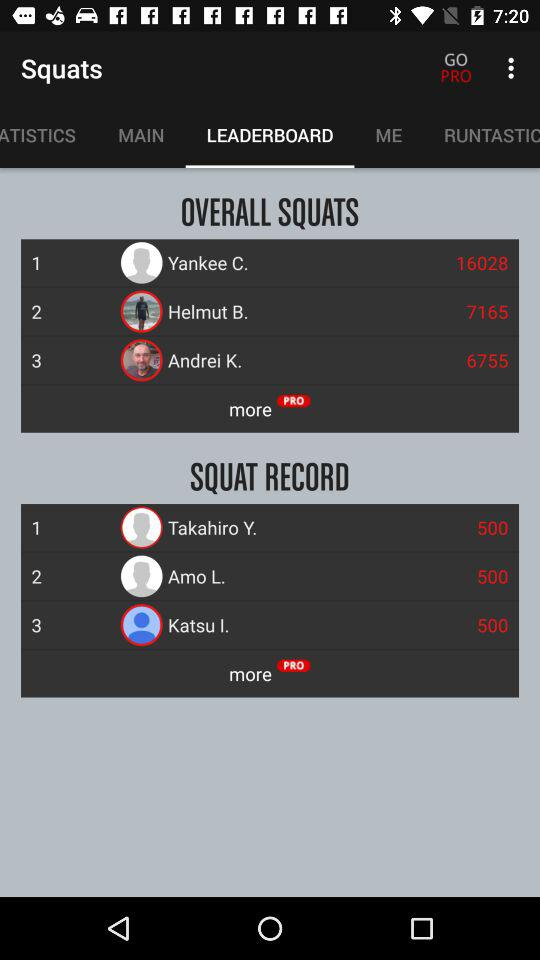What is a Squat Record?
When the provided information is insufficient, respond with <no answer>. <no answer> 